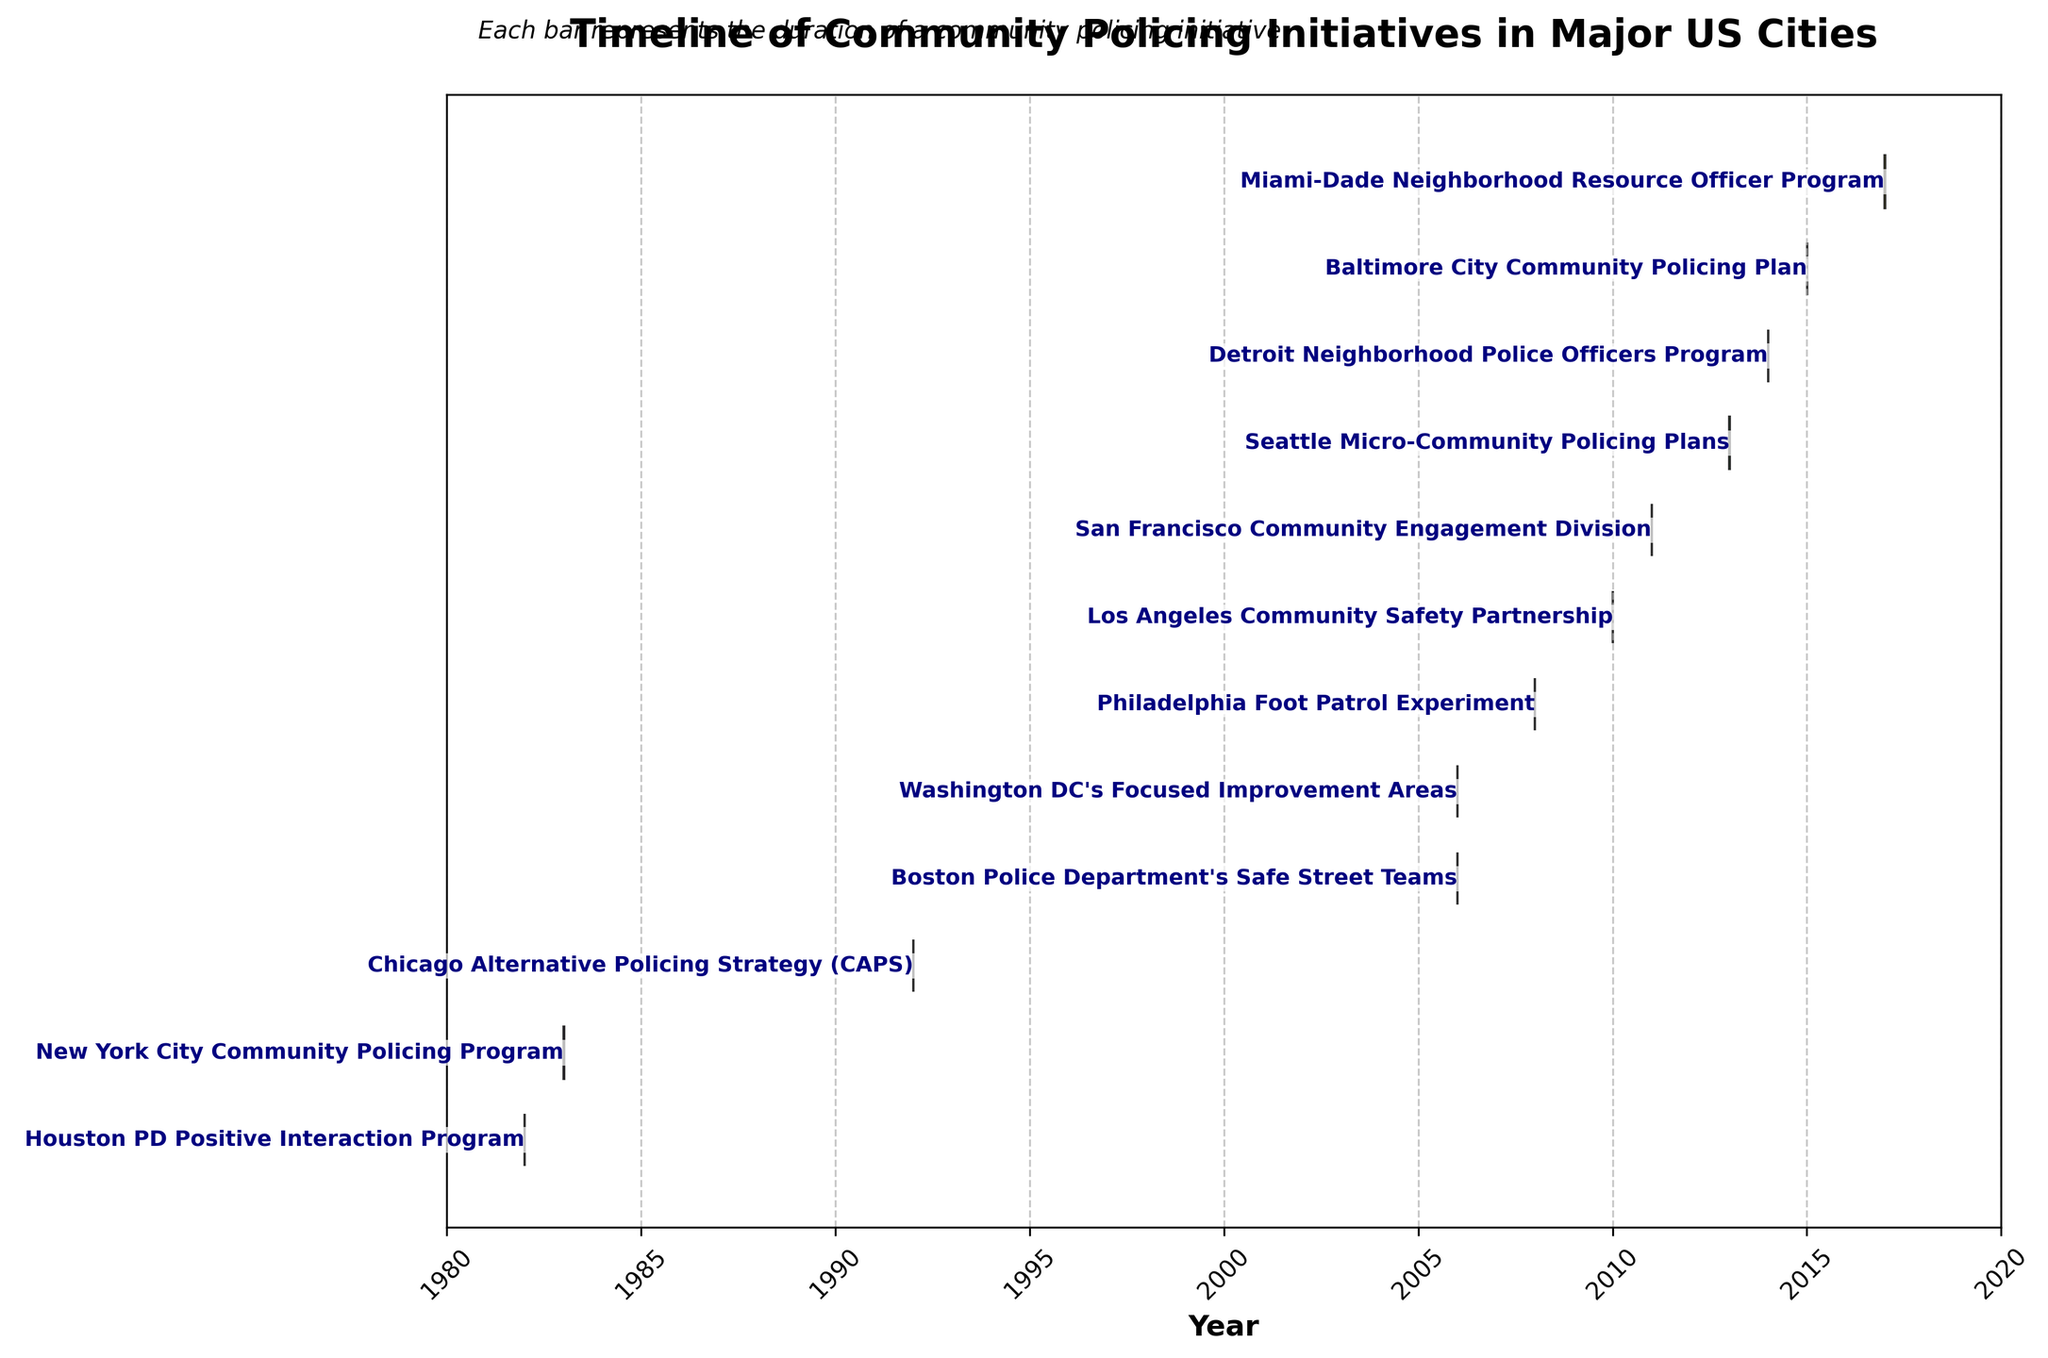What is the title of the Gantt Chart? The title of the chart is usually located at the top of the figure, indicating what the entire visualization is about. In this case, the title provides an overview of the content.
Answer: Timeline of Community Policing Initiatives in Major US Cities Which initiative started first, and in which year? Look for the leftmost bar in the Gantt Chart. The task bar that starts the earliest represents the first initiative. The label next to this bar will indicate its name and corresponding year.
Answer: Houston PD Positive Interaction Program, 1983 How many initiatives were implemented between 2010 and 2020? Examine the timeline on the x-axis to identify the range from 2010 to 2020. Count the number of bars that fall within this range either partially or entirely.
Answer: 6 Which city had more recent initiatives starting after 2015? Identify the tasks that begin after 2015 by checking the start date of each bar. Count the instances where the start date is later than 2015. The task labels will indicate the name of the city.
Answer: Miami-Dade and Baltimore What is the longest-duration community policing initiative, and how many years did it last? Look for the longest bar on the Gantt Chart. The label next to it will indicate the name of the initiative. To find how many years it lasted, calculate the difference between the end and start years.
Answer: New York City Community Policing Program, 6 years What are the start and end years for the Seattle Micro-Community Policing Plans? Find the respective bar labeled "Seattle Micro-Community Policing Plans" on the Gantt Chart. The ends of the bar indicate the starting and ending years.
Answer: 2014 to 2016 Which two initiatives have the same duration and what is the duration? Identify bars that have the same length visually. Comparing the labels and the lengths will tell you which ones are equal.
Answer: Boston Police Department's Safe Street Teams and Washington DC's Focused Improvement Areas, 2 years Between Los Angeles Community Safety Partnership and Philadelphia Foot Patrol Experiment, which one concluded first? Locate the bars for both initiatives and compare their ending points on the timeline. The bar that ends first concluded first.
Answer: Philadelphia Foot Patrol Experiment What is the average duration of all the initiatives? First, determine the duration for each initiative by taking the difference between their end and start years. Then, calculate the average by summing these durations and dividing by the total number of initiatives.
Answer: 2.75 years 